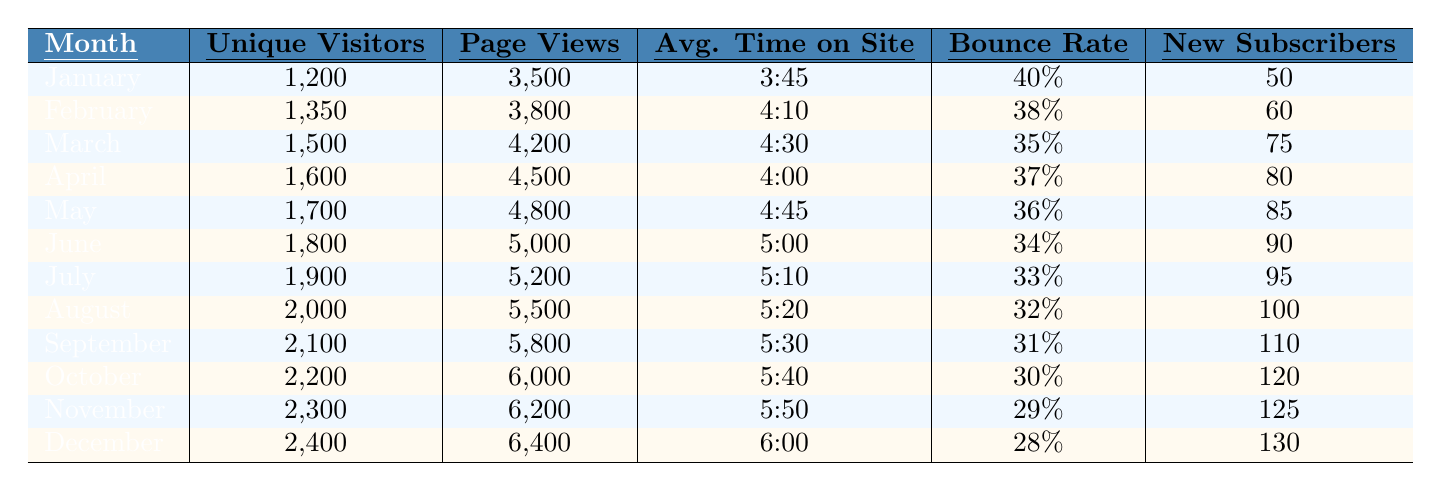What was the unique visitor count in June? The table lists the unique visitors for each month, and for June it is shown as 1800.
Answer: 1800 What is the average time on site for April? According to the table, the average time on site for April is presented as 4:00.
Answer: 4:00 Which month had the highest bounce rate? The bounce rates for each month are provided, and December has the highest bounce rate at 28%.
Answer: December How many new subscribers were there in the month of October? The table shows that the number of new subscribers in October was 120.
Answer: 120 What is the total number of unique visitors from January to March? The unique visitor counts for January, February, and March are 1200, 1350, and 1500 respectively. Adding them gives 1200 + 1350 + 1500 = 4050.
Answer: 4050 By how many new subscribers did the blog grow from January to December? The new subscribers in January is 50, and in December it's 130. The growth is 130 - 50 = 80.
Answer: 80 What was the average page views per month for the first half of the year (January to June)? The page views for January through June are 3500, 3800, 4200, 4500, 4800, and 5000. The total is 3500 + 3800 + 4200 + 4500 + 4800 + 5000 = 25800. Dividing by 6 months gives 25800 / 6 = 4300.
Answer: 4300 Did the blog see an increase in unique visitors every month? Each month's unique visitor count is increasing throughout the year, confirming there was consistent growth.
Answer: Yes Which month had the lowest average time on site? The average time on site for each month is listed, and January has the lowest at 3:45.
Answer: January How much did the bounce rate decrease from January to October? The bounce rate in January is 40%, and in October it is 30%. The decrease is 40% - 30% = 10%.
Answer: 10% What is the total number of page views in the second half of 2023 (July to December)? The page views from July to December are 5200, 5500, 5800, 6000, 6200, and 6400. Summing these gives 5200 + 5500 + 5800 + 6000 + 6200 + 6400 = 36600.
Answer: 36600 